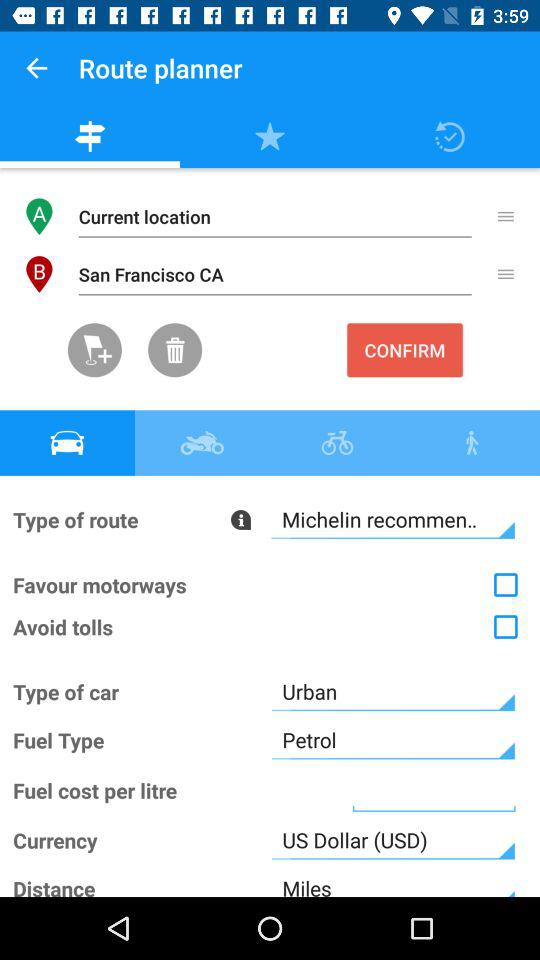What is the route type? The route type is "Michelin recommen..". 